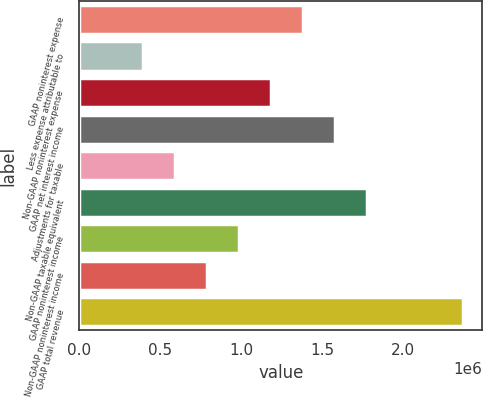Convert chart. <chart><loc_0><loc_0><loc_500><loc_500><bar_chart><fcel>GAAP noninterest expense<fcel>Less expense attributable to<fcel>Non-GAAP noninterest expense<fcel>GAAP net interest income<fcel>Adjustments for taxable<fcel>Non-GAAP taxable equivalent<fcel>GAAP noninterest income<fcel>Non-GAAP noninterest income<fcel>GAAP total revenue<nl><fcel>1.38434e+06<fcel>395561<fcel>1.18658e+06<fcel>1.58209e+06<fcel>593316<fcel>1.77985e+06<fcel>988826<fcel>791071<fcel>2.37311e+06<nl></chart> 